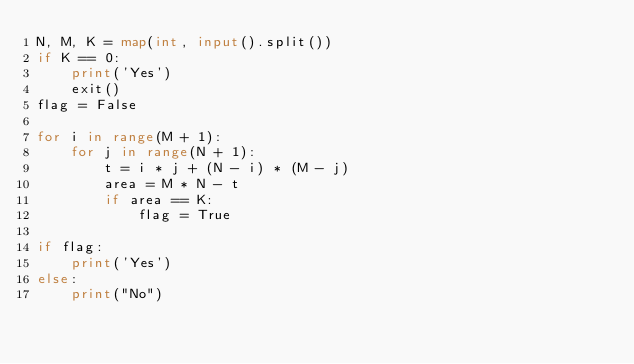<code> <loc_0><loc_0><loc_500><loc_500><_Python_>N, M, K = map(int, input().split())
if K == 0:
    print('Yes')
    exit()
flag = False

for i in range(M + 1):
    for j in range(N + 1):
        t = i * j + (N - i) * (M - j)
        area = M * N - t
        if area == K:
            flag = True

if flag:
    print('Yes')
else:
    print("No")</code> 